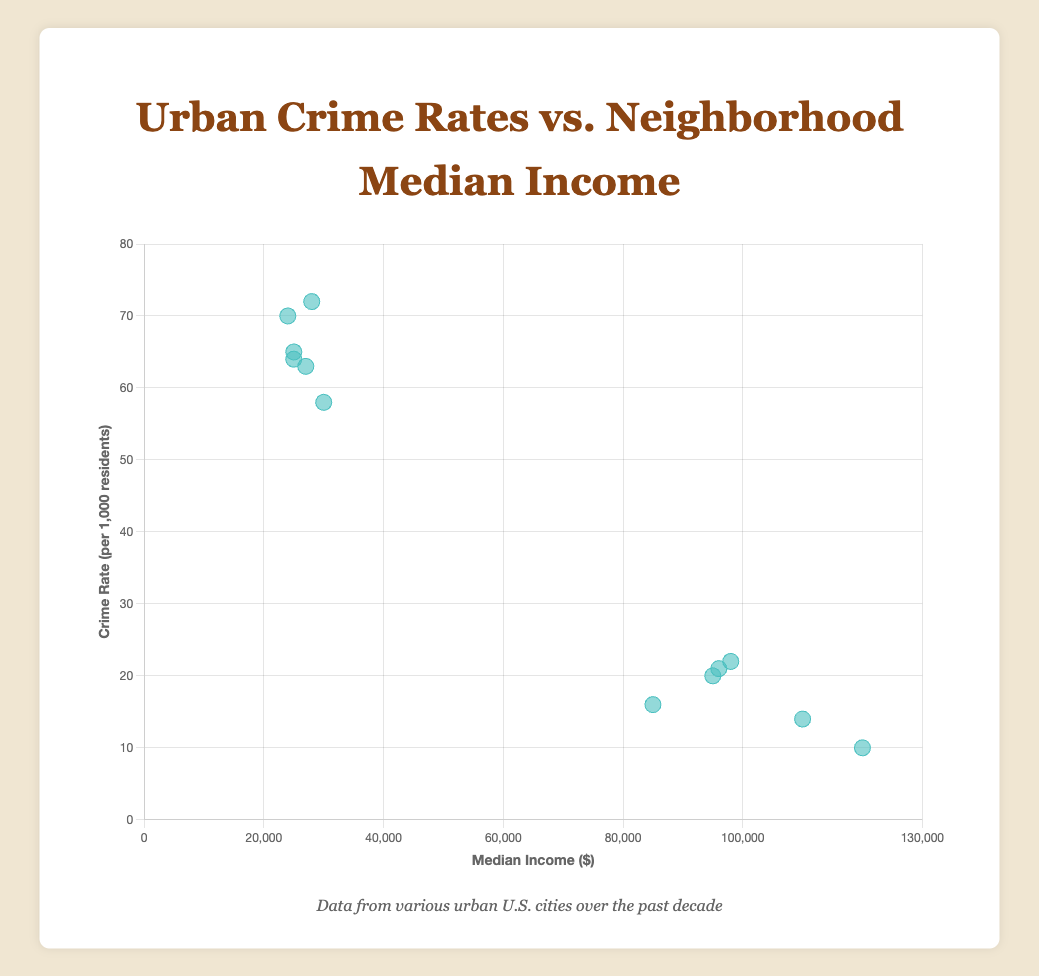What is the highest crime rate observed in the figure? The highest crime rate is observed in the "South Central" neighborhood of Los Angeles, with a crime rate of 72 per 1,000 residents.
Answer: 72 Which city has a neighborhood with the lowest crime rate? The "River Oaks" neighborhood in Houston has the lowest crime rate of 10 per 1,000 residents.
Answer: Houston How many neighborhoods have a crime rate higher than 60 per 1,000 residents? There are four neighborhoods with a crime rate higher than 60 per 1,000 residents: "Englewood" in Chicago, "Brownsville" in New York, "South Central" in Los Angeles, and "Kensington" in Philadelphia.
Answer: 4 Is there a general trend between median income and crime rate in the figure? The trend line in the figure shows a negative correlation between median income and crime rate, indicating that higher median incomes are associated with lower crime rates.
Answer: Higher income, lower crime rate Which neighborhood has the highest median income, and what is its crime rate? The "River Oaks" neighborhood in Houston has the highest median income of $120,000, with a crime rate of 10 per 1,000 residents.
Answer: River Oaks, 10 What's the difference in crime rate between the "Englewood" neighborhood in Chicago and "Lincoln Park" neighborhood in Chicago? The crime rate in "Englewood" is 64 per 1,000 residents, while in "Lincoln Park" it is 21 per 1,000. The difference is 64 - 21 = 43.
Answer: 43 What is the color and shape of the data points representing the neighborhoods in the figure? The data points representing the neighborhoods are circular and have a light teal color.
Answer: Circular, light teal Give the median crime rate among all the neighborhoods shown. The neighborhoods have the following crime rates: [64, 21, 16, 58, 14, 72, 10, 65, 22, 70, 20, 63]. Arranging them in ascending order: [10, 14, 16, 20, 21, 22, 58, 63, 64, 65, 70, 72]. The median value (middle) of this even number of data points is (22 + 58) / 2 = 40.
Answer: 40 Which neighborhood in Atlanta has a lower crime rate, and what is the figure? The "Buckhead" neighborhood in Atlanta has a lower crime rate of 20 per 1,000 residents compared to "Mechanicsville".
Answer: Buckhead, 20 Is there any neighborhood with a median income around $50,000 and a crime rate around 50 per 1,000 residents? No, there are no neighborhoods with a median income around $50,000 and a crime rate around 50 per 1,000 residents. The data points do not show such a combination.
Answer: No 